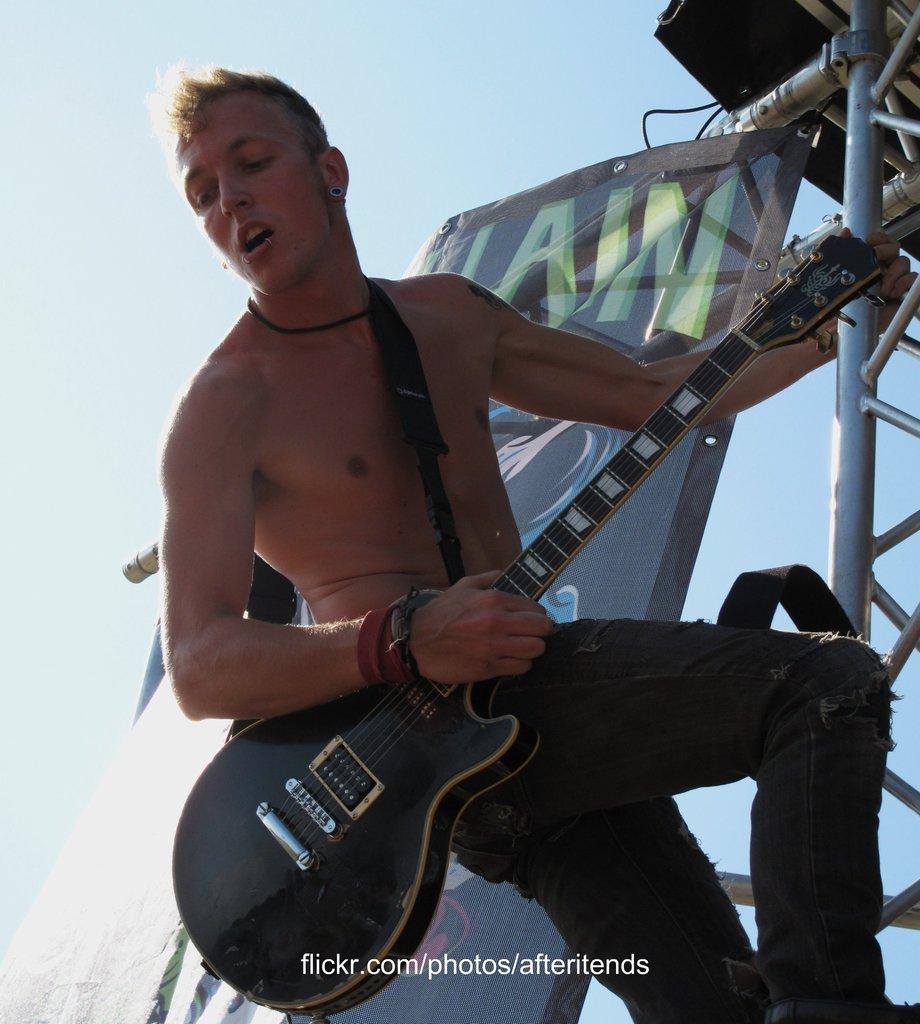What is the man in the image holding in his hands? The man is holding a guitar and a rod in his hands. What might the man be doing with the guitar? The man might be playing the guitar, as it is a musical instrument. Can you describe the background of the image? There is a banner in the background of the image. How does the man control the donkey in the image? There is no donkey present in the image, so it is not possible to answer that question. 